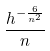Convert formula to latex. <formula><loc_0><loc_0><loc_500><loc_500>\frac { h ^ { - \frac { 6 } { n ^ { 2 } } } } { n }</formula> 